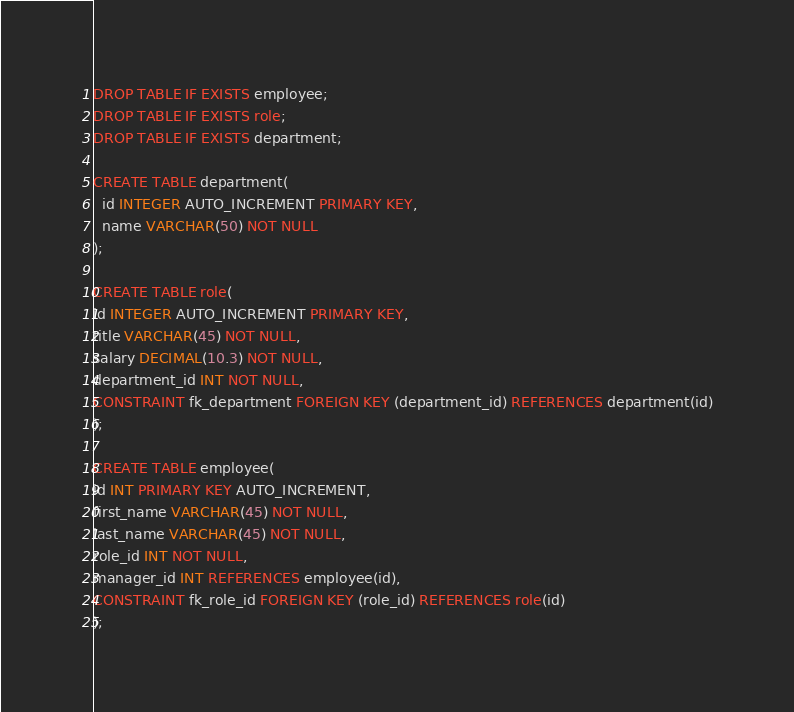Convert code to text. <code><loc_0><loc_0><loc_500><loc_500><_SQL_>DROP TABLE IF EXISTS employee;
DROP TABLE IF EXISTS role;
DROP TABLE IF EXISTS department;

CREATE TABLE department(
  id INTEGER AUTO_INCREMENT PRIMARY KEY,
  name VARCHAR(50) NOT NULL
);

CREATE TABLE role(
id INTEGER AUTO_INCREMENT PRIMARY KEY,
title VARCHAR(45) NOT NULL,
salary DECIMAL(10.3) NOT NULL,
department_id INT NOT NULL,
CONSTRAINT fk_department FOREIGN KEY (department_id) REFERENCES department(id)
);

CREATE TABLE employee(
id INT PRIMARY KEY AUTO_INCREMENT,
first_name VARCHAR(45) NOT NULL,
last_name VARCHAR(45) NOT NULL,
role_id INT NOT NULL,
manager_id INT REFERENCES employee(id),
CONSTRAINT fk_role_id FOREIGN KEY (role_id) REFERENCES role(id)
);</code> 